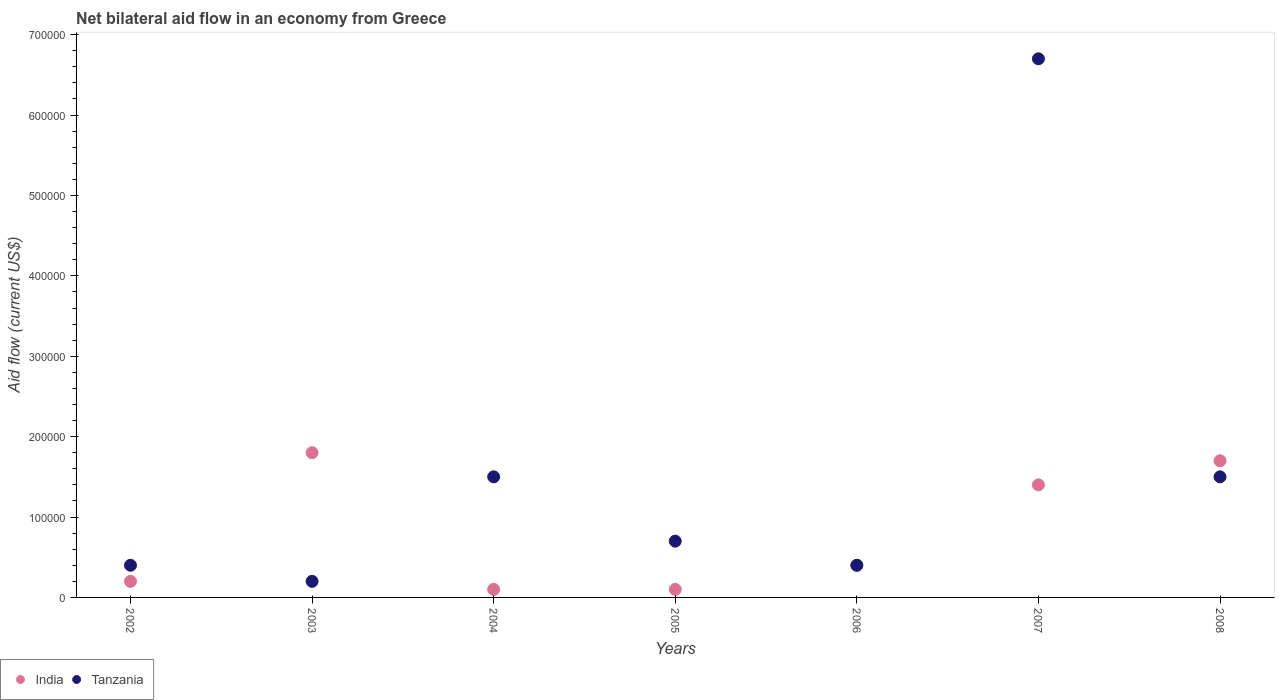How many different coloured dotlines are there?
Your answer should be very brief. 2. Across all years, what is the maximum net bilateral aid flow in India?
Ensure brevity in your answer.  1.80e+05. Across all years, what is the minimum net bilateral aid flow in India?
Offer a terse response. 10000. What is the total net bilateral aid flow in India in the graph?
Provide a short and direct response. 5.70e+05. What is the difference between the net bilateral aid flow in Tanzania in 2004 and that in 2006?
Provide a succinct answer. 1.10e+05. What is the difference between the net bilateral aid flow in Tanzania in 2002 and the net bilateral aid flow in India in 2007?
Offer a terse response. -1.00e+05. What is the average net bilateral aid flow in Tanzania per year?
Offer a very short reply. 1.63e+05. What is the ratio of the net bilateral aid flow in India in 2004 to that in 2005?
Offer a terse response. 1. Is the net bilateral aid flow in India in 2005 less than that in 2008?
Provide a succinct answer. Yes. What is the difference between the highest and the lowest net bilateral aid flow in Tanzania?
Offer a very short reply. 6.50e+05. Does the net bilateral aid flow in Tanzania monotonically increase over the years?
Offer a terse response. No. Is the net bilateral aid flow in India strictly greater than the net bilateral aid flow in Tanzania over the years?
Your answer should be compact. No. Is the net bilateral aid flow in India strictly less than the net bilateral aid flow in Tanzania over the years?
Your answer should be very brief. No. How many dotlines are there?
Your answer should be very brief. 2. How many years are there in the graph?
Your response must be concise. 7. Are the values on the major ticks of Y-axis written in scientific E-notation?
Your response must be concise. No. Where does the legend appear in the graph?
Give a very brief answer. Bottom left. How many legend labels are there?
Keep it short and to the point. 2. How are the legend labels stacked?
Provide a short and direct response. Horizontal. What is the title of the graph?
Offer a very short reply. Net bilateral aid flow in an economy from Greece. Does "Timor-Leste" appear as one of the legend labels in the graph?
Keep it short and to the point. No. What is the label or title of the X-axis?
Offer a terse response. Years. What is the label or title of the Y-axis?
Your answer should be very brief. Aid flow (current US$). What is the Aid flow (current US$) in India in 2002?
Provide a succinct answer. 2.00e+04. What is the Aid flow (current US$) in Tanzania in 2002?
Offer a terse response. 4.00e+04. What is the Aid flow (current US$) of India in 2003?
Your answer should be compact. 1.80e+05. What is the Aid flow (current US$) in Tanzania in 2004?
Offer a terse response. 1.50e+05. What is the Aid flow (current US$) of Tanzania in 2005?
Your answer should be very brief. 7.00e+04. What is the Aid flow (current US$) of Tanzania in 2006?
Your answer should be compact. 4.00e+04. What is the Aid flow (current US$) in India in 2007?
Make the answer very short. 1.40e+05. What is the Aid flow (current US$) in Tanzania in 2007?
Offer a terse response. 6.70e+05. What is the Aid flow (current US$) in India in 2008?
Your answer should be compact. 1.70e+05. What is the Aid flow (current US$) of Tanzania in 2008?
Make the answer very short. 1.50e+05. Across all years, what is the maximum Aid flow (current US$) of India?
Provide a succinct answer. 1.80e+05. Across all years, what is the maximum Aid flow (current US$) in Tanzania?
Provide a short and direct response. 6.70e+05. Across all years, what is the minimum Aid flow (current US$) of India?
Give a very brief answer. 10000. What is the total Aid flow (current US$) in India in the graph?
Your answer should be compact. 5.70e+05. What is the total Aid flow (current US$) in Tanzania in the graph?
Provide a short and direct response. 1.14e+06. What is the difference between the Aid flow (current US$) in Tanzania in 2002 and that in 2003?
Provide a succinct answer. 2.00e+04. What is the difference between the Aid flow (current US$) of India in 2002 and that in 2004?
Offer a terse response. 10000. What is the difference between the Aid flow (current US$) of India in 2002 and that in 2005?
Give a very brief answer. 10000. What is the difference between the Aid flow (current US$) in India in 2002 and that in 2006?
Provide a succinct answer. -2.00e+04. What is the difference between the Aid flow (current US$) in India in 2002 and that in 2007?
Offer a terse response. -1.20e+05. What is the difference between the Aid flow (current US$) in Tanzania in 2002 and that in 2007?
Make the answer very short. -6.30e+05. What is the difference between the Aid flow (current US$) of India in 2002 and that in 2008?
Offer a terse response. -1.50e+05. What is the difference between the Aid flow (current US$) in Tanzania in 2003 and that in 2004?
Make the answer very short. -1.30e+05. What is the difference between the Aid flow (current US$) in India in 2003 and that in 2005?
Keep it short and to the point. 1.70e+05. What is the difference between the Aid flow (current US$) of India in 2003 and that in 2006?
Offer a terse response. 1.40e+05. What is the difference between the Aid flow (current US$) of Tanzania in 2003 and that in 2007?
Keep it short and to the point. -6.50e+05. What is the difference between the Aid flow (current US$) in Tanzania in 2003 and that in 2008?
Your answer should be very brief. -1.30e+05. What is the difference between the Aid flow (current US$) of India in 2004 and that in 2005?
Ensure brevity in your answer.  0. What is the difference between the Aid flow (current US$) in Tanzania in 2004 and that in 2005?
Make the answer very short. 8.00e+04. What is the difference between the Aid flow (current US$) in Tanzania in 2004 and that in 2006?
Make the answer very short. 1.10e+05. What is the difference between the Aid flow (current US$) of Tanzania in 2004 and that in 2007?
Ensure brevity in your answer.  -5.20e+05. What is the difference between the Aid flow (current US$) of India in 2005 and that in 2006?
Ensure brevity in your answer.  -3.00e+04. What is the difference between the Aid flow (current US$) of India in 2005 and that in 2007?
Your answer should be very brief. -1.30e+05. What is the difference between the Aid flow (current US$) of Tanzania in 2005 and that in 2007?
Your answer should be compact. -6.00e+05. What is the difference between the Aid flow (current US$) of India in 2005 and that in 2008?
Provide a short and direct response. -1.60e+05. What is the difference between the Aid flow (current US$) in Tanzania in 2005 and that in 2008?
Ensure brevity in your answer.  -8.00e+04. What is the difference between the Aid flow (current US$) in India in 2006 and that in 2007?
Keep it short and to the point. -1.00e+05. What is the difference between the Aid flow (current US$) of Tanzania in 2006 and that in 2007?
Keep it short and to the point. -6.30e+05. What is the difference between the Aid flow (current US$) in India in 2006 and that in 2008?
Ensure brevity in your answer.  -1.30e+05. What is the difference between the Aid flow (current US$) in Tanzania in 2007 and that in 2008?
Offer a very short reply. 5.20e+05. What is the difference between the Aid flow (current US$) of India in 2002 and the Aid flow (current US$) of Tanzania in 2003?
Make the answer very short. 0. What is the difference between the Aid flow (current US$) of India in 2002 and the Aid flow (current US$) of Tanzania in 2006?
Provide a short and direct response. -2.00e+04. What is the difference between the Aid flow (current US$) of India in 2002 and the Aid flow (current US$) of Tanzania in 2007?
Offer a very short reply. -6.50e+05. What is the difference between the Aid flow (current US$) of India in 2002 and the Aid flow (current US$) of Tanzania in 2008?
Offer a very short reply. -1.30e+05. What is the difference between the Aid flow (current US$) of India in 2003 and the Aid flow (current US$) of Tanzania in 2005?
Give a very brief answer. 1.10e+05. What is the difference between the Aid flow (current US$) in India in 2003 and the Aid flow (current US$) in Tanzania in 2007?
Ensure brevity in your answer.  -4.90e+05. What is the difference between the Aid flow (current US$) in India in 2004 and the Aid flow (current US$) in Tanzania in 2005?
Give a very brief answer. -6.00e+04. What is the difference between the Aid flow (current US$) of India in 2004 and the Aid flow (current US$) of Tanzania in 2006?
Give a very brief answer. -3.00e+04. What is the difference between the Aid flow (current US$) of India in 2004 and the Aid flow (current US$) of Tanzania in 2007?
Your response must be concise. -6.60e+05. What is the difference between the Aid flow (current US$) of India in 2005 and the Aid flow (current US$) of Tanzania in 2007?
Keep it short and to the point. -6.60e+05. What is the difference between the Aid flow (current US$) of India in 2005 and the Aid flow (current US$) of Tanzania in 2008?
Your answer should be compact. -1.40e+05. What is the difference between the Aid flow (current US$) of India in 2006 and the Aid flow (current US$) of Tanzania in 2007?
Make the answer very short. -6.30e+05. What is the difference between the Aid flow (current US$) in India in 2006 and the Aid flow (current US$) in Tanzania in 2008?
Provide a succinct answer. -1.10e+05. What is the average Aid flow (current US$) of India per year?
Keep it short and to the point. 8.14e+04. What is the average Aid flow (current US$) in Tanzania per year?
Your answer should be compact. 1.63e+05. In the year 2003, what is the difference between the Aid flow (current US$) of India and Aid flow (current US$) of Tanzania?
Your answer should be compact. 1.60e+05. In the year 2004, what is the difference between the Aid flow (current US$) in India and Aid flow (current US$) in Tanzania?
Give a very brief answer. -1.40e+05. In the year 2006, what is the difference between the Aid flow (current US$) of India and Aid flow (current US$) of Tanzania?
Offer a very short reply. 0. In the year 2007, what is the difference between the Aid flow (current US$) in India and Aid flow (current US$) in Tanzania?
Ensure brevity in your answer.  -5.30e+05. What is the ratio of the Aid flow (current US$) of India in 2002 to that in 2003?
Your response must be concise. 0.11. What is the ratio of the Aid flow (current US$) of India in 2002 to that in 2004?
Ensure brevity in your answer.  2. What is the ratio of the Aid flow (current US$) in Tanzania in 2002 to that in 2004?
Your answer should be very brief. 0.27. What is the ratio of the Aid flow (current US$) of Tanzania in 2002 to that in 2005?
Your answer should be very brief. 0.57. What is the ratio of the Aid flow (current US$) of India in 2002 to that in 2006?
Give a very brief answer. 0.5. What is the ratio of the Aid flow (current US$) of Tanzania in 2002 to that in 2006?
Offer a terse response. 1. What is the ratio of the Aid flow (current US$) in India in 2002 to that in 2007?
Keep it short and to the point. 0.14. What is the ratio of the Aid flow (current US$) in Tanzania in 2002 to that in 2007?
Provide a short and direct response. 0.06. What is the ratio of the Aid flow (current US$) of India in 2002 to that in 2008?
Your answer should be compact. 0.12. What is the ratio of the Aid flow (current US$) in Tanzania in 2002 to that in 2008?
Your response must be concise. 0.27. What is the ratio of the Aid flow (current US$) in India in 2003 to that in 2004?
Give a very brief answer. 18. What is the ratio of the Aid flow (current US$) of Tanzania in 2003 to that in 2004?
Your answer should be very brief. 0.13. What is the ratio of the Aid flow (current US$) in Tanzania in 2003 to that in 2005?
Your answer should be very brief. 0.29. What is the ratio of the Aid flow (current US$) in Tanzania in 2003 to that in 2006?
Keep it short and to the point. 0.5. What is the ratio of the Aid flow (current US$) of Tanzania in 2003 to that in 2007?
Provide a succinct answer. 0.03. What is the ratio of the Aid flow (current US$) in India in 2003 to that in 2008?
Ensure brevity in your answer.  1.06. What is the ratio of the Aid flow (current US$) in Tanzania in 2003 to that in 2008?
Provide a succinct answer. 0.13. What is the ratio of the Aid flow (current US$) of India in 2004 to that in 2005?
Give a very brief answer. 1. What is the ratio of the Aid flow (current US$) in Tanzania in 2004 to that in 2005?
Ensure brevity in your answer.  2.14. What is the ratio of the Aid flow (current US$) in Tanzania in 2004 to that in 2006?
Make the answer very short. 3.75. What is the ratio of the Aid flow (current US$) in India in 2004 to that in 2007?
Your response must be concise. 0.07. What is the ratio of the Aid flow (current US$) in Tanzania in 2004 to that in 2007?
Provide a short and direct response. 0.22. What is the ratio of the Aid flow (current US$) of India in 2004 to that in 2008?
Provide a succinct answer. 0.06. What is the ratio of the Aid flow (current US$) of India in 2005 to that in 2007?
Your response must be concise. 0.07. What is the ratio of the Aid flow (current US$) in Tanzania in 2005 to that in 2007?
Provide a short and direct response. 0.1. What is the ratio of the Aid flow (current US$) of India in 2005 to that in 2008?
Provide a succinct answer. 0.06. What is the ratio of the Aid flow (current US$) of Tanzania in 2005 to that in 2008?
Provide a short and direct response. 0.47. What is the ratio of the Aid flow (current US$) of India in 2006 to that in 2007?
Provide a succinct answer. 0.29. What is the ratio of the Aid flow (current US$) of Tanzania in 2006 to that in 2007?
Give a very brief answer. 0.06. What is the ratio of the Aid flow (current US$) of India in 2006 to that in 2008?
Your answer should be very brief. 0.24. What is the ratio of the Aid flow (current US$) of Tanzania in 2006 to that in 2008?
Keep it short and to the point. 0.27. What is the ratio of the Aid flow (current US$) in India in 2007 to that in 2008?
Provide a short and direct response. 0.82. What is the ratio of the Aid flow (current US$) in Tanzania in 2007 to that in 2008?
Keep it short and to the point. 4.47. What is the difference between the highest and the second highest Aid flow (current US$) of India?
Offer a terse response. 10000. What is the difference between the highest and the second highest Aid flow (current US$) in Tanzania?
Your answer should be very brief. 5.20e+05. What is the difference between the highest and the lowest Aid flow (current US$) in India?
Your answer should be very brief. 1.70e+05. What is the difference between the highest and the lowest Aid flow (current US$) of Tanzania?
Provide a succinct answer. 6.50e+05. 